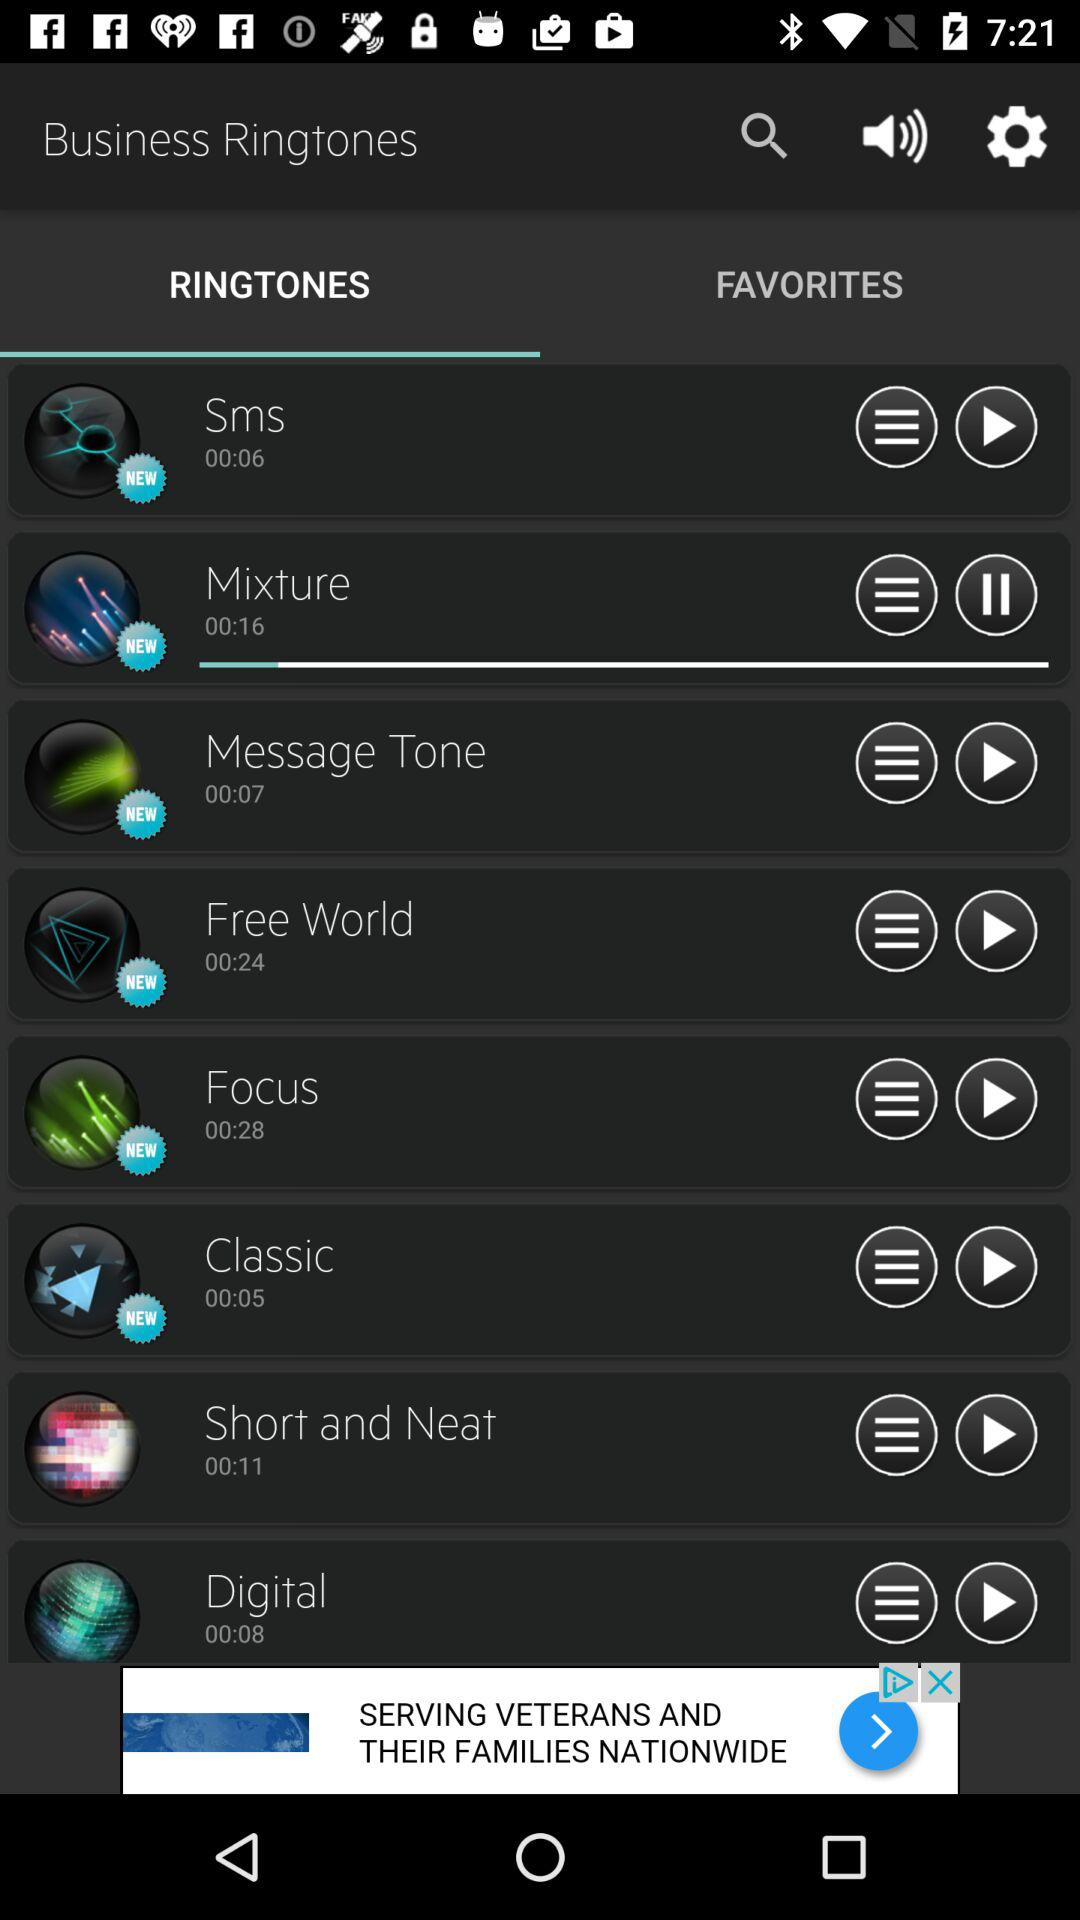What is the length of the mixture? The length of the mixture is 16 seconds. 